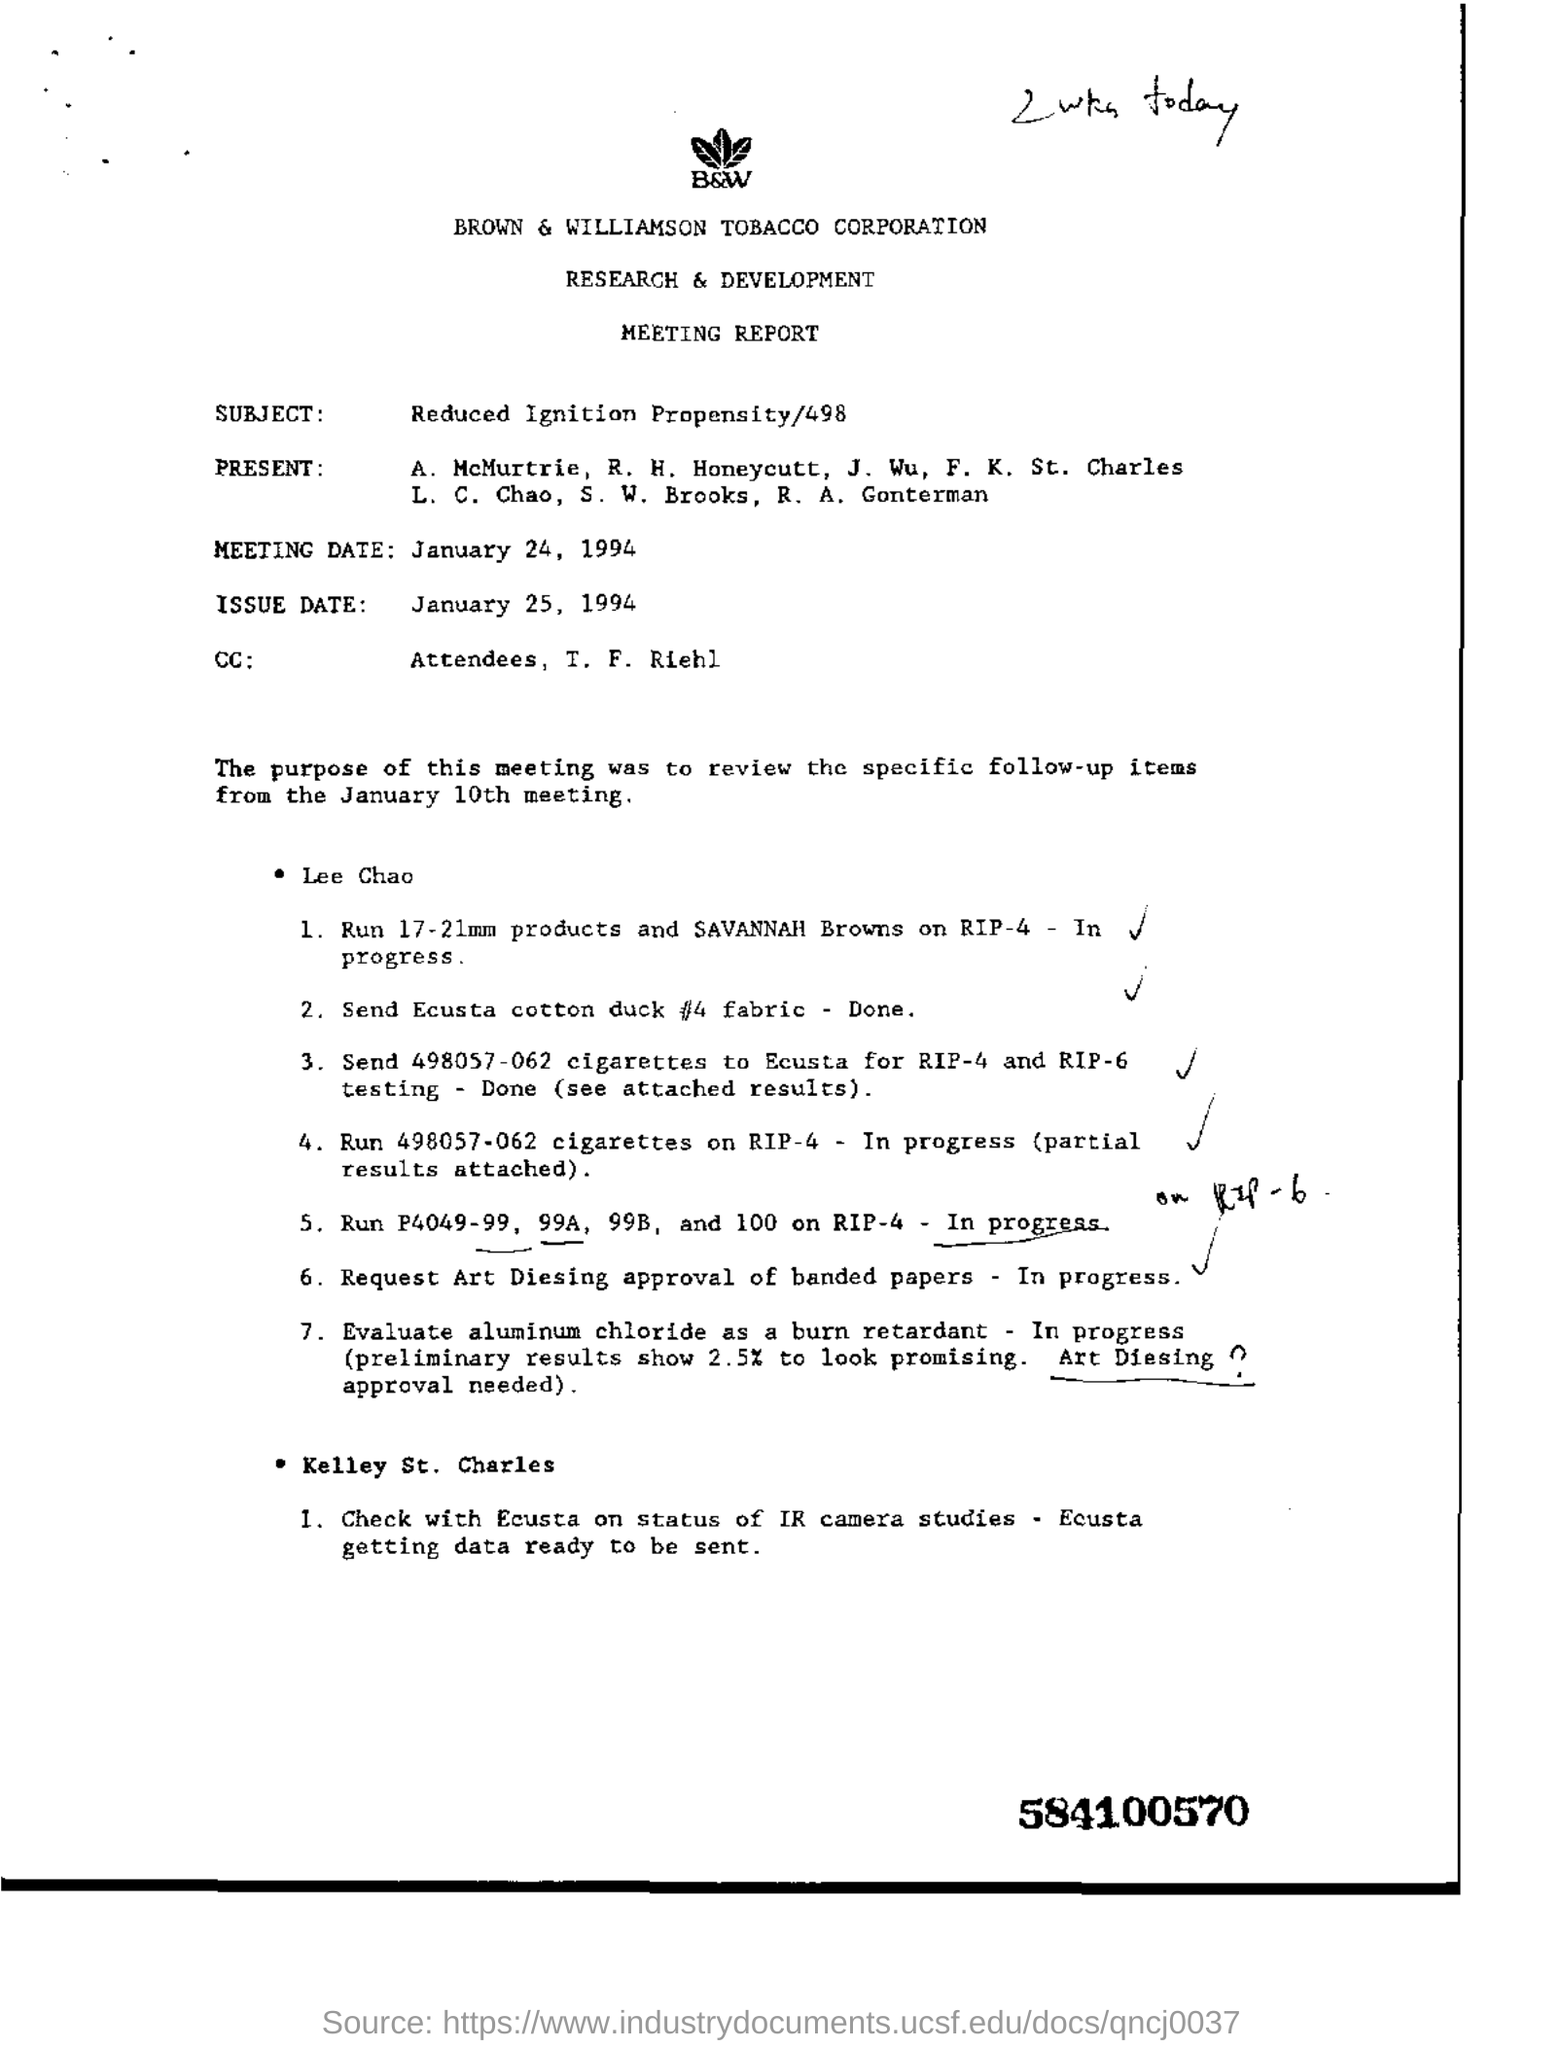Draw attention to some important aspects in this diagram. The meeting date is January 24, 1994. I declare that the name of the corporation is BROWN & WILLIAMSON TOBACCO corporation. The subject is reduced ignition propensity, as specified in 498. 